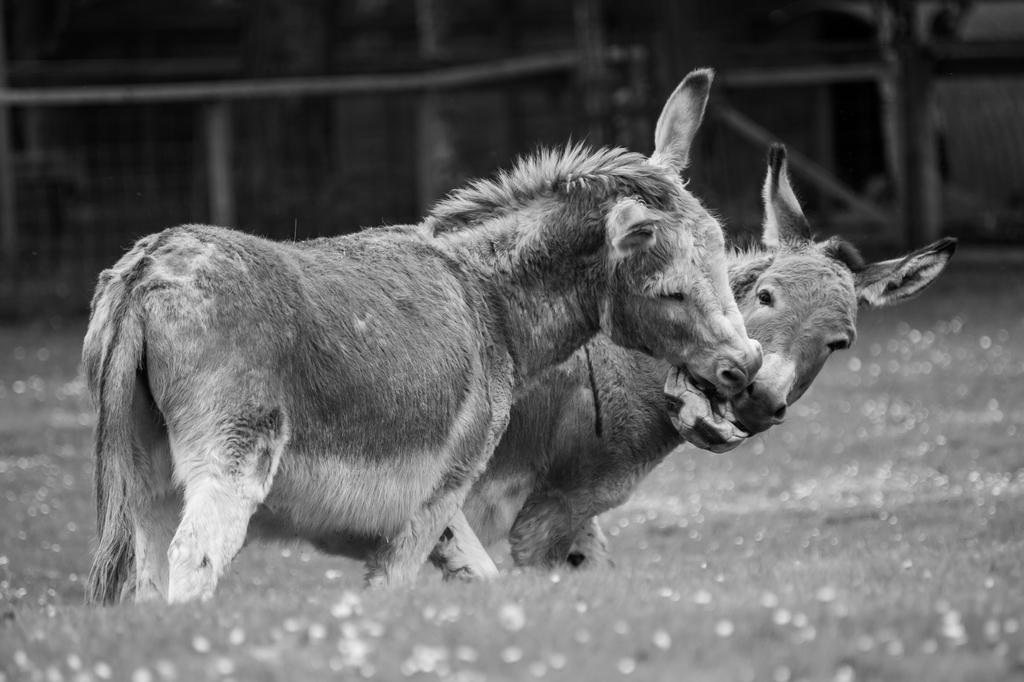What animals are present in the image? There are two donkeys in the image. What activity are the donkeys engaged in? The donkeys are playing with a ball. What can be seen in the background of the image? There is fencing in the background of the image. What type of blade is being used by the donkeys in the image? There is no blade present in the image; the donkeys are playing with a ball. What rule is being enforced by the donkeys in the image? There is no rule being enforced by the donkeys in the image; they are simply playing with a ball. 